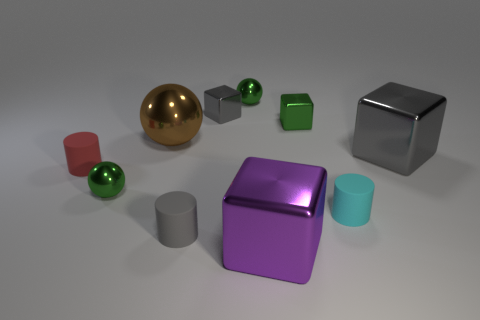What is the shape of the red thing that is the same size as the cyan matte cylinder?
Provide a succinct answer. Cylinder. How many objects are gray objects that are left of the big gray block or small shiny cubes that are to the left of the purple metal thing?
Offer a very short reply. 2. Are there fewer large rubber cylinders than red objects?
Make the answer very short. Yes. What material is the cyan cylinder that is the same size as the red matte thing?
Provide a succinct answer. Rubber. Is the size of the gray shiny cube that is to the right of the large purple block the same as the brown sphere on the left side of the purple object?
Your response must be concise. Yes. Is there a gray block that has the same material as the tiny gray cylinder?
Your answer should be very brief. No. How many things are large objects that are left of the big purple object or small gray cylinders?
Your answer should be compact. 2. Is the material of the sphere that is behind the brown metal ball the same as the cyan thing?
Ensure brevity in your answer.  No. Is the shape of the purple thing the same as the large gray thing?
Make the answer very short. Yes. There is a ball on the left side of the brown metallic ball; how many tiny cylinders are to the left of it?
Offer a terse response. 1. 